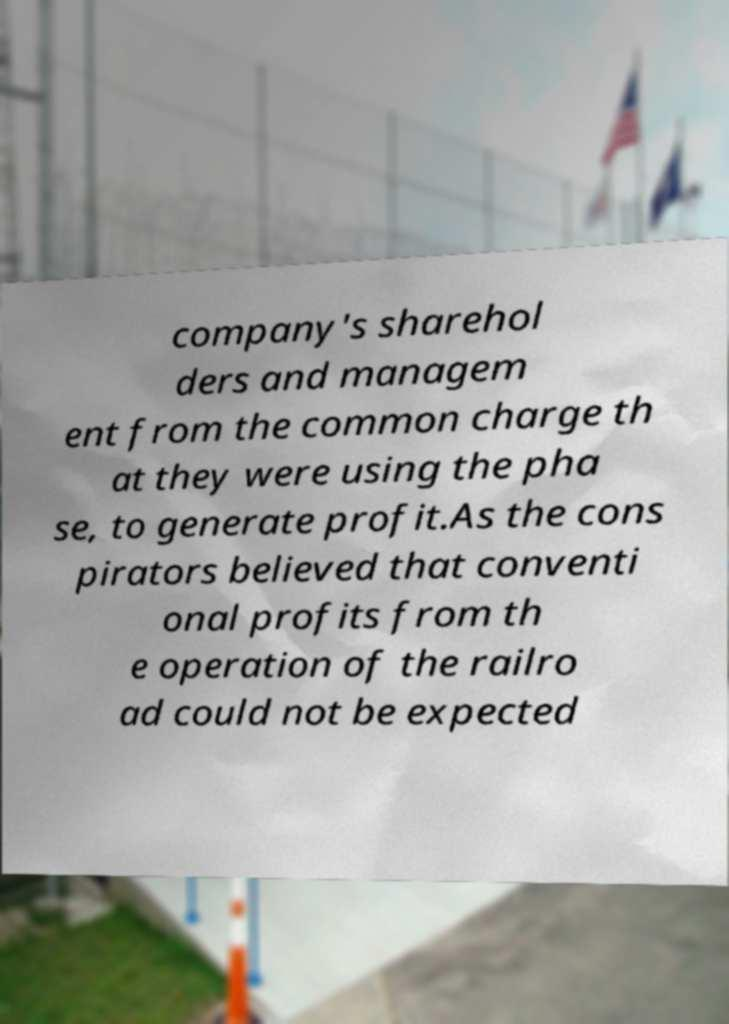Could you assist in decoding the text presented in this image and type it out clearly? company's sharehol ders and managem ent from the common charge th at they were using the pha se, to generate profit.As the cons pirators believed that conventi onal profits from th e operation of the railro ad could not be expected 